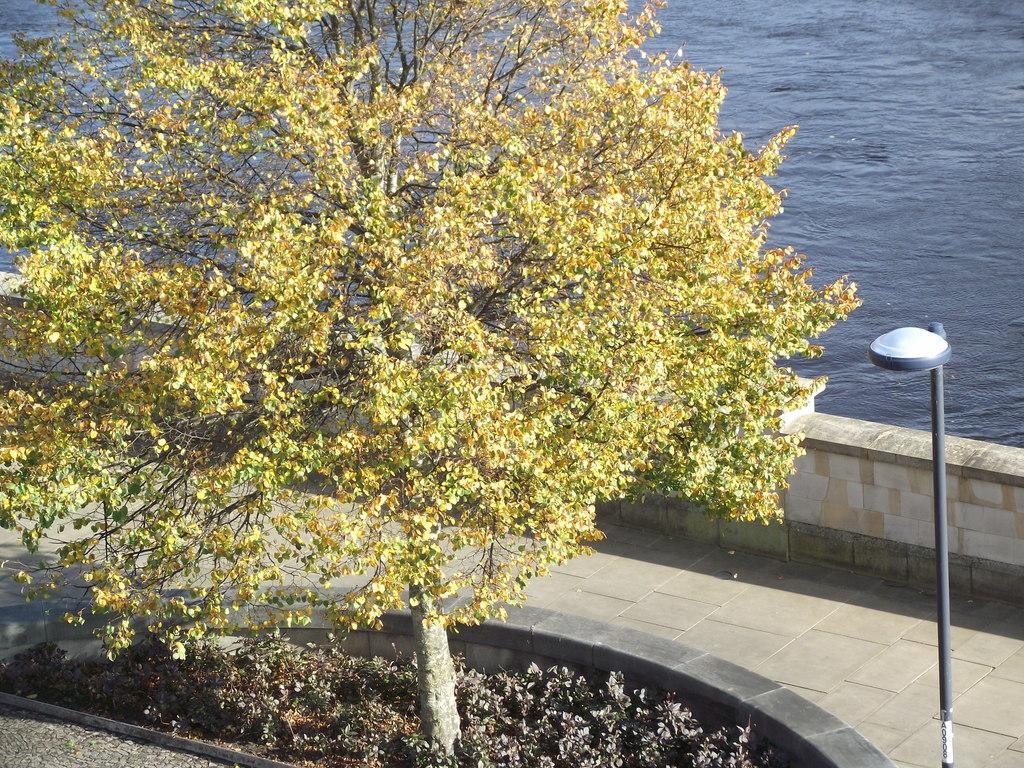Please provide a concise description of this image. In the center of the image we can see a tree. On the bottom we can see plants. On the right there is a street light. In the background we can see water. Here we can see wall. 